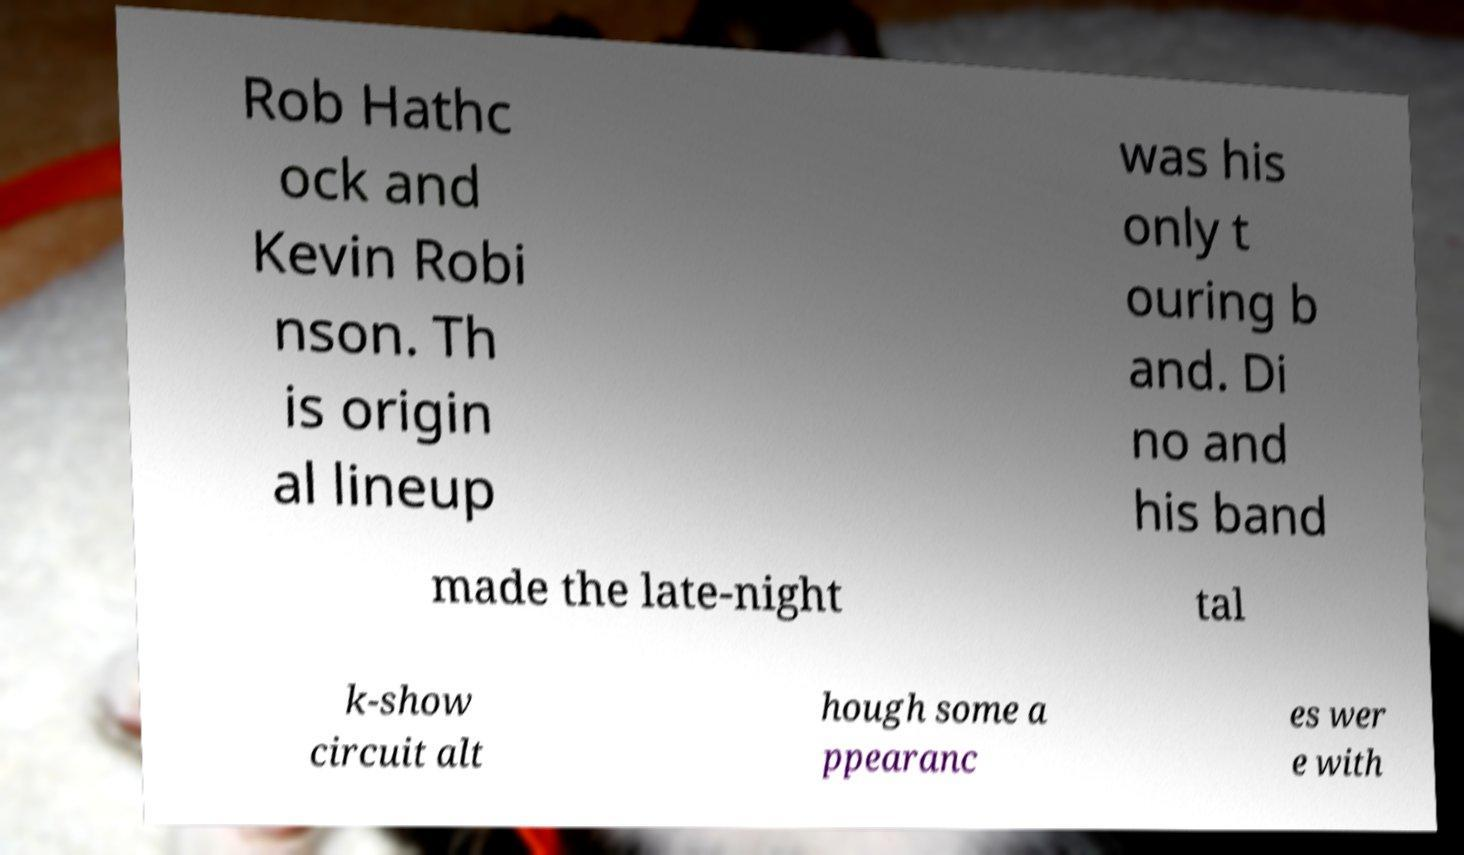Could you assist in decoding the text presented in this image and type it out clearly? Rob Hathc ock and Kevin Robi nson. Th is origin al lineup was his only t ouring b and. Di no and his band made the late-night tal k-show circuit alt hough some a ppearanc es wer e with 